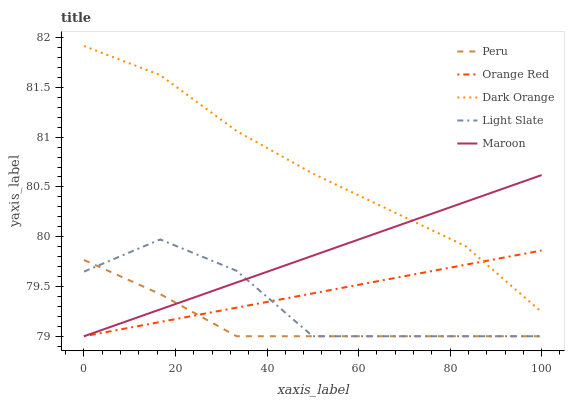Does Peru have the minimum area under the curve?
Answer yes or no. Yes. Does Dark Orange have the maximum area under the curve?
Answer yes or no. Yes. Does Maroon have the minimum area under the curve?
Answer yes or no. No. Does Maroon have the maximum area under the curve?
Answer yes or no. No. Is Maroon the smoothest?
Answer yes or no. Yes. Is Light Slate the roughest?
Answer yes or no. Yes. Is Dark Orange the smoothest?
Answer yes or no. No. Is Dark Orange the roughest?
Answer yes or no. No. Does Dark Orange have the lowest value?
Answer yes or no. No. Does Dark Orange have the highest value?
Answer yes or no. Yes. Does Maroon have the highest value?
Answer yes or no. No. Is Light Slate less than Dark Orange?
Answer yes or no. Yes. Is Dark Orange greater than Light Slate?
Answer yes or no. Yes. Does Light Slate intersect Dark Orange?
Answer yes or no. No. 